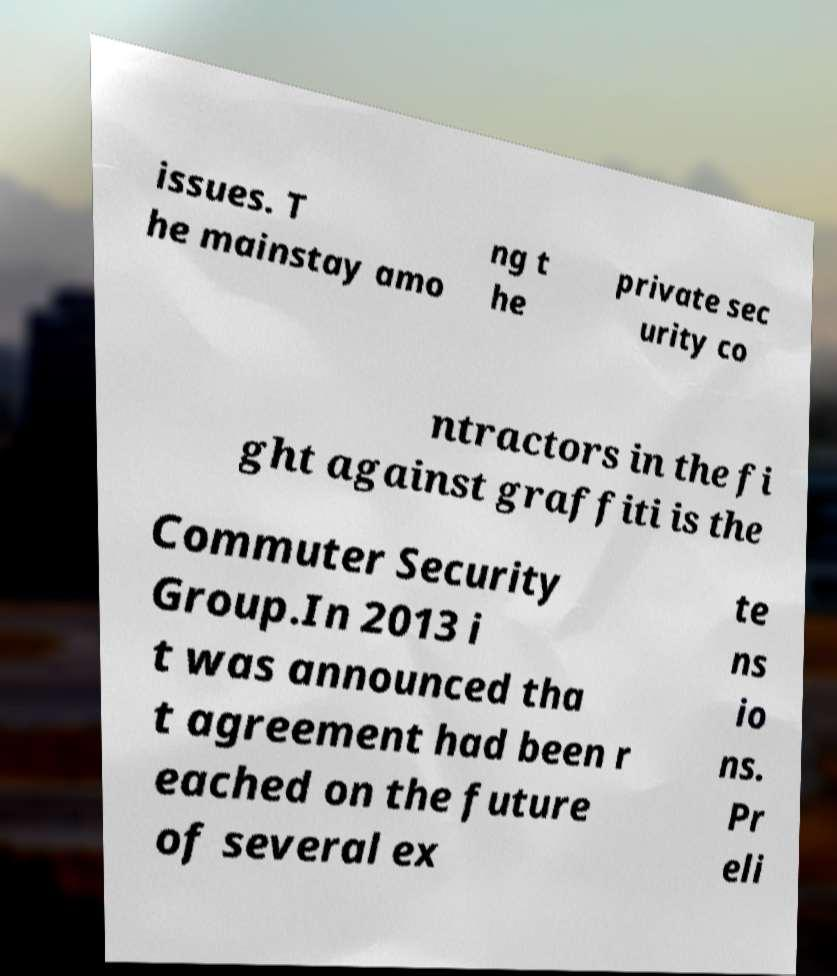What messages or text are displayed in this image? I need them in a readable, typed format. issues. T he mainstay amo ng t he private sec urity co ntractors in the fi ght against graffiti is the Commuter Security Group.In 2013 i t was announced tha t agreement had been r eached on the future of several ex te ns io ns. Pr eli 